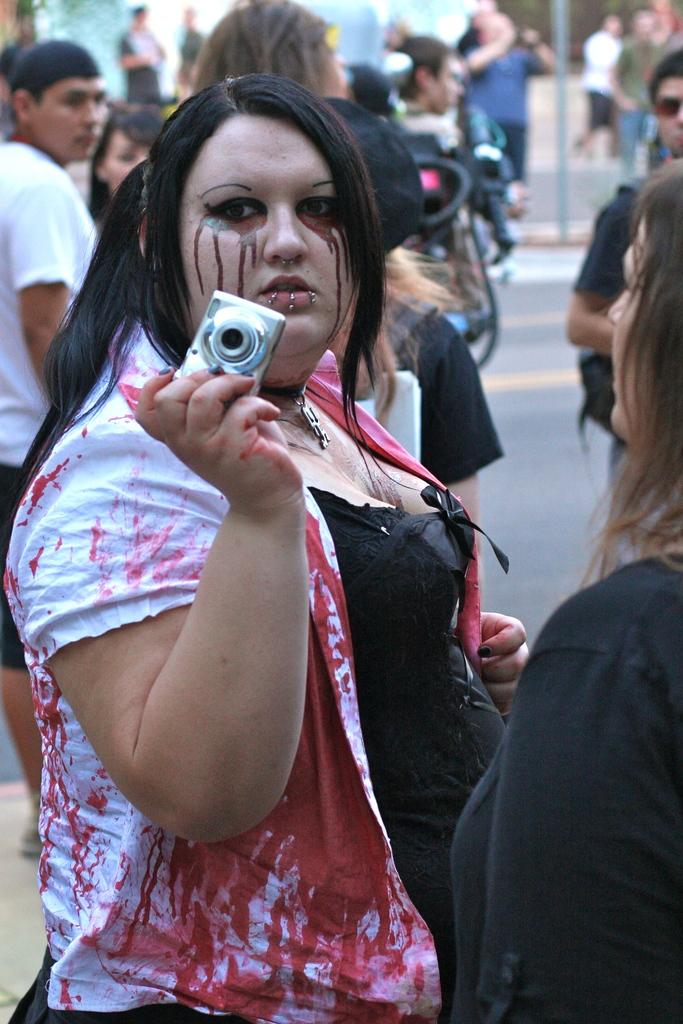Who is the main subject in the image? There is a woman in the image. What is the woman wearing? The woman is wearing a white and red shirt. What is the woman holding in her right hand? The woman is holding a camera in her right hand. Can you describe the people behind the woman? There is a group of people behind the woman. What type of dinosaurs can be seen in the image? There are no dinosaurs present in the image. What angle is the camera set at in the image? The angle of the camera cannot be determined from the image, as it is the woman who is holding the camera. 